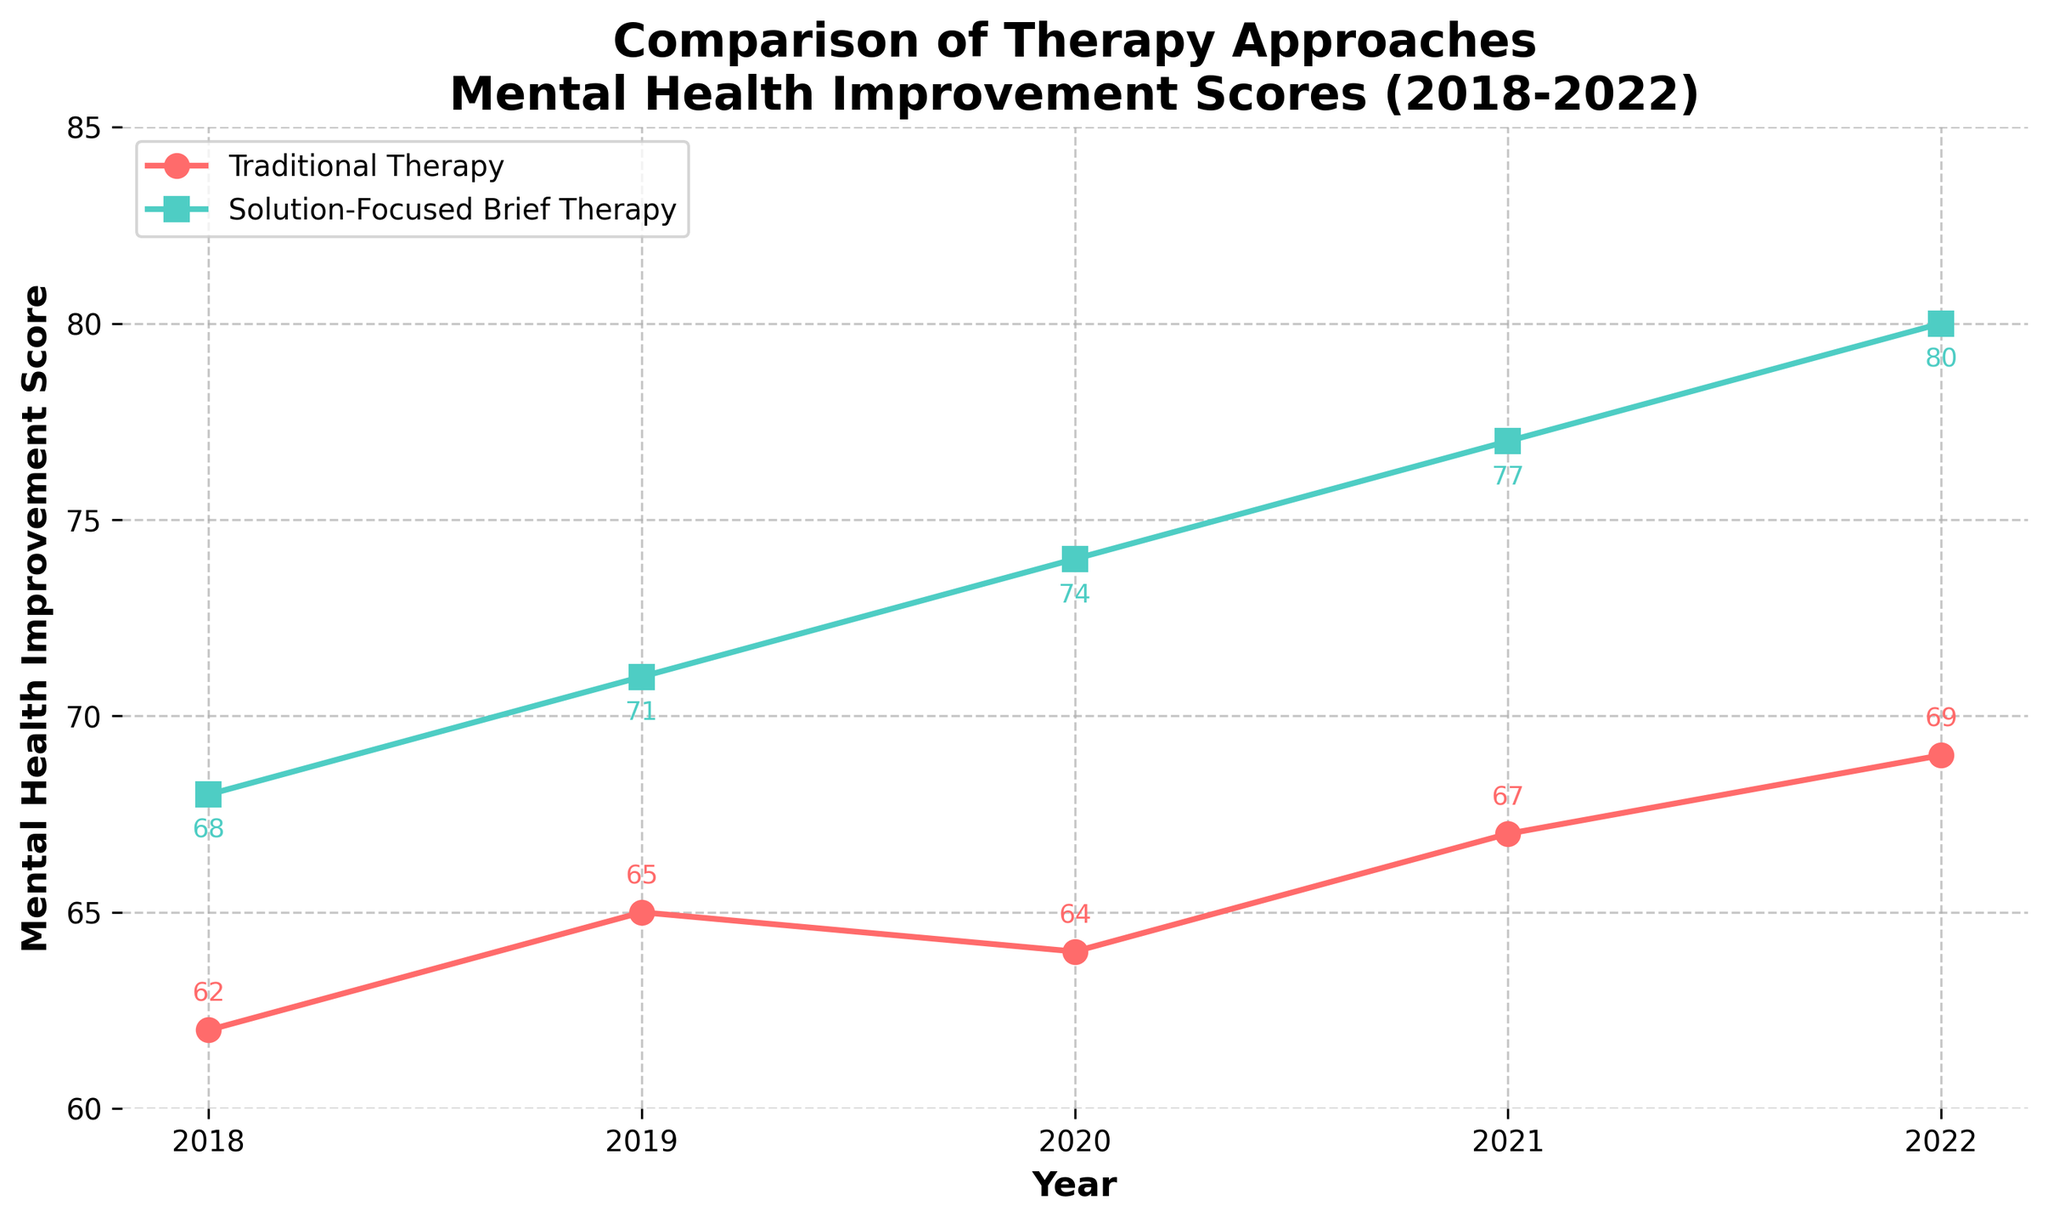What's the difference in mental health improvement scores between Solution-Focused Brief Therapy and Traditional Therapy in 2022? Check the scores for both therapies in 2022. Solution-Focused Brief Therapy has a score of 80, and Traditional Therapy has a score of 69. Subtract 69 from 80.
Answer: 11 Which year shows the largest improvement for Traditional Therapy from the previous year? Compare the yearly changes: from 2018 to 2019 (+3), 2019 to 2020 (-1), 2020 to 2021 (+3), and 2021 to 2022 (+2). The largest improvement is between 2018 and 2019 or between 2020 and 2021, which are both +3.
Answer: 2018 to 2019 Which therapy shows a consistent upward trend in the scores over the 5-year period? Examine the trend for each therapy: Solution-Focused Brief Therapy consistently increases from 68 to 80, while Traditional Therapy fluctuates. Solution-Focused Brief Therapy has a consistent upward trend.
Answer: Solution-Focused Brief Therapy What is the average mental health improvement score for Traditional Therapy over the 5-year period? Sum the scores for Traditional Therapy (62 + 65 + 64 + 67 + 69) = 327. Divide by the number of years (5).
Answer: 65.4 Which year did both therapies show the same amount of improvement from the previous year? Calculate the yearly improvement for both therapies and compare: 
- Traditional Therapy: 2018-2019 (+3), 2019-2020 (-1), 2020-2021 (+3), 2021-2022 (+2).
- Solution-Focused Brief Therapy: 2018-2019 (+3), 2019-2020 (+3), 2020-2021 (+3), 2021-2022 (+3).
The same amount of improvement is in 2018-2019 when both improve by +3.
Answer: 2018-2019 Which year did Solution-Focused Brief Therapy surpass a score of 75? Check the scores for each year: Solution-Focused Brief Therapy surpassed 75 in 2021 when the score is 77.
Answer: 2021 What is the score difference between the two therapies in 2020? Look at the scores in 2020: Traditional Therapy has a score of 64, and Solution-Focused Brief Therapy has a score of 74. Subtract 64 from 74.
Answer: 10 Which therapy had a higher improvement score in 2018? Compare the scores in 2018: Traditional Therapy has a score of 62, and Solution-Focused Brief Therapy has a score of 68. Solution-Focused Brief Therapy has the higher score.
Answer: Solution-Focused Brief Therapy By how much did the mental health improvement score for Solution-Focused Brief Therapy increase from 2018 to 2022? Subtract the 2018 score (68) from the 2022 score (80).
Answer: 12 Which year did Traditional Therapy see a decline in its mental health improvement score? Identify the years with declining scores: from 2019 to 2020, the score decreased from 65 to 64.
Answer: 2020 